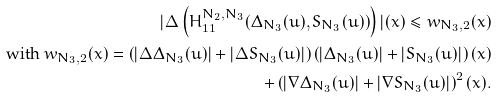Convert formula to latex. <formula><loc_0><loc_0><loc_500><loc_500>| { \mathbf \Delta } \left ( H _ { 1 1 } ^ { N _ { 2 } , N _ { 3 } } ( \Delta _ { N _ { 3 } } ( u ) , S _ { N _ { 3 } } ( u ) ) \right ) | ( x ) \leq w _ { N _ { 3 } , 2 } ( x ) \\ \text { with } w _ { N _ { 3 } , 2 } ( x ) = \left ( | { \mathbf \Delta } \Delta _ { N _ { 3 } } ( u ) | + | { \mathbf \Delta } S _ { N _ { 3 } } ( u ) | \right ) \left ( | \Delta _ { N _ { 3 } } ( u ) | + | S _ { N _ { 3 } } ( u ) | \right ) ( x ) \\ + \left ( | \nabla \Delta _ { N _ { 3 } } ( u ) | + | \nabla S _ { N _ { 3 } } ( u ) | \right ) ^ { 2 } ( x ) .</formula> 